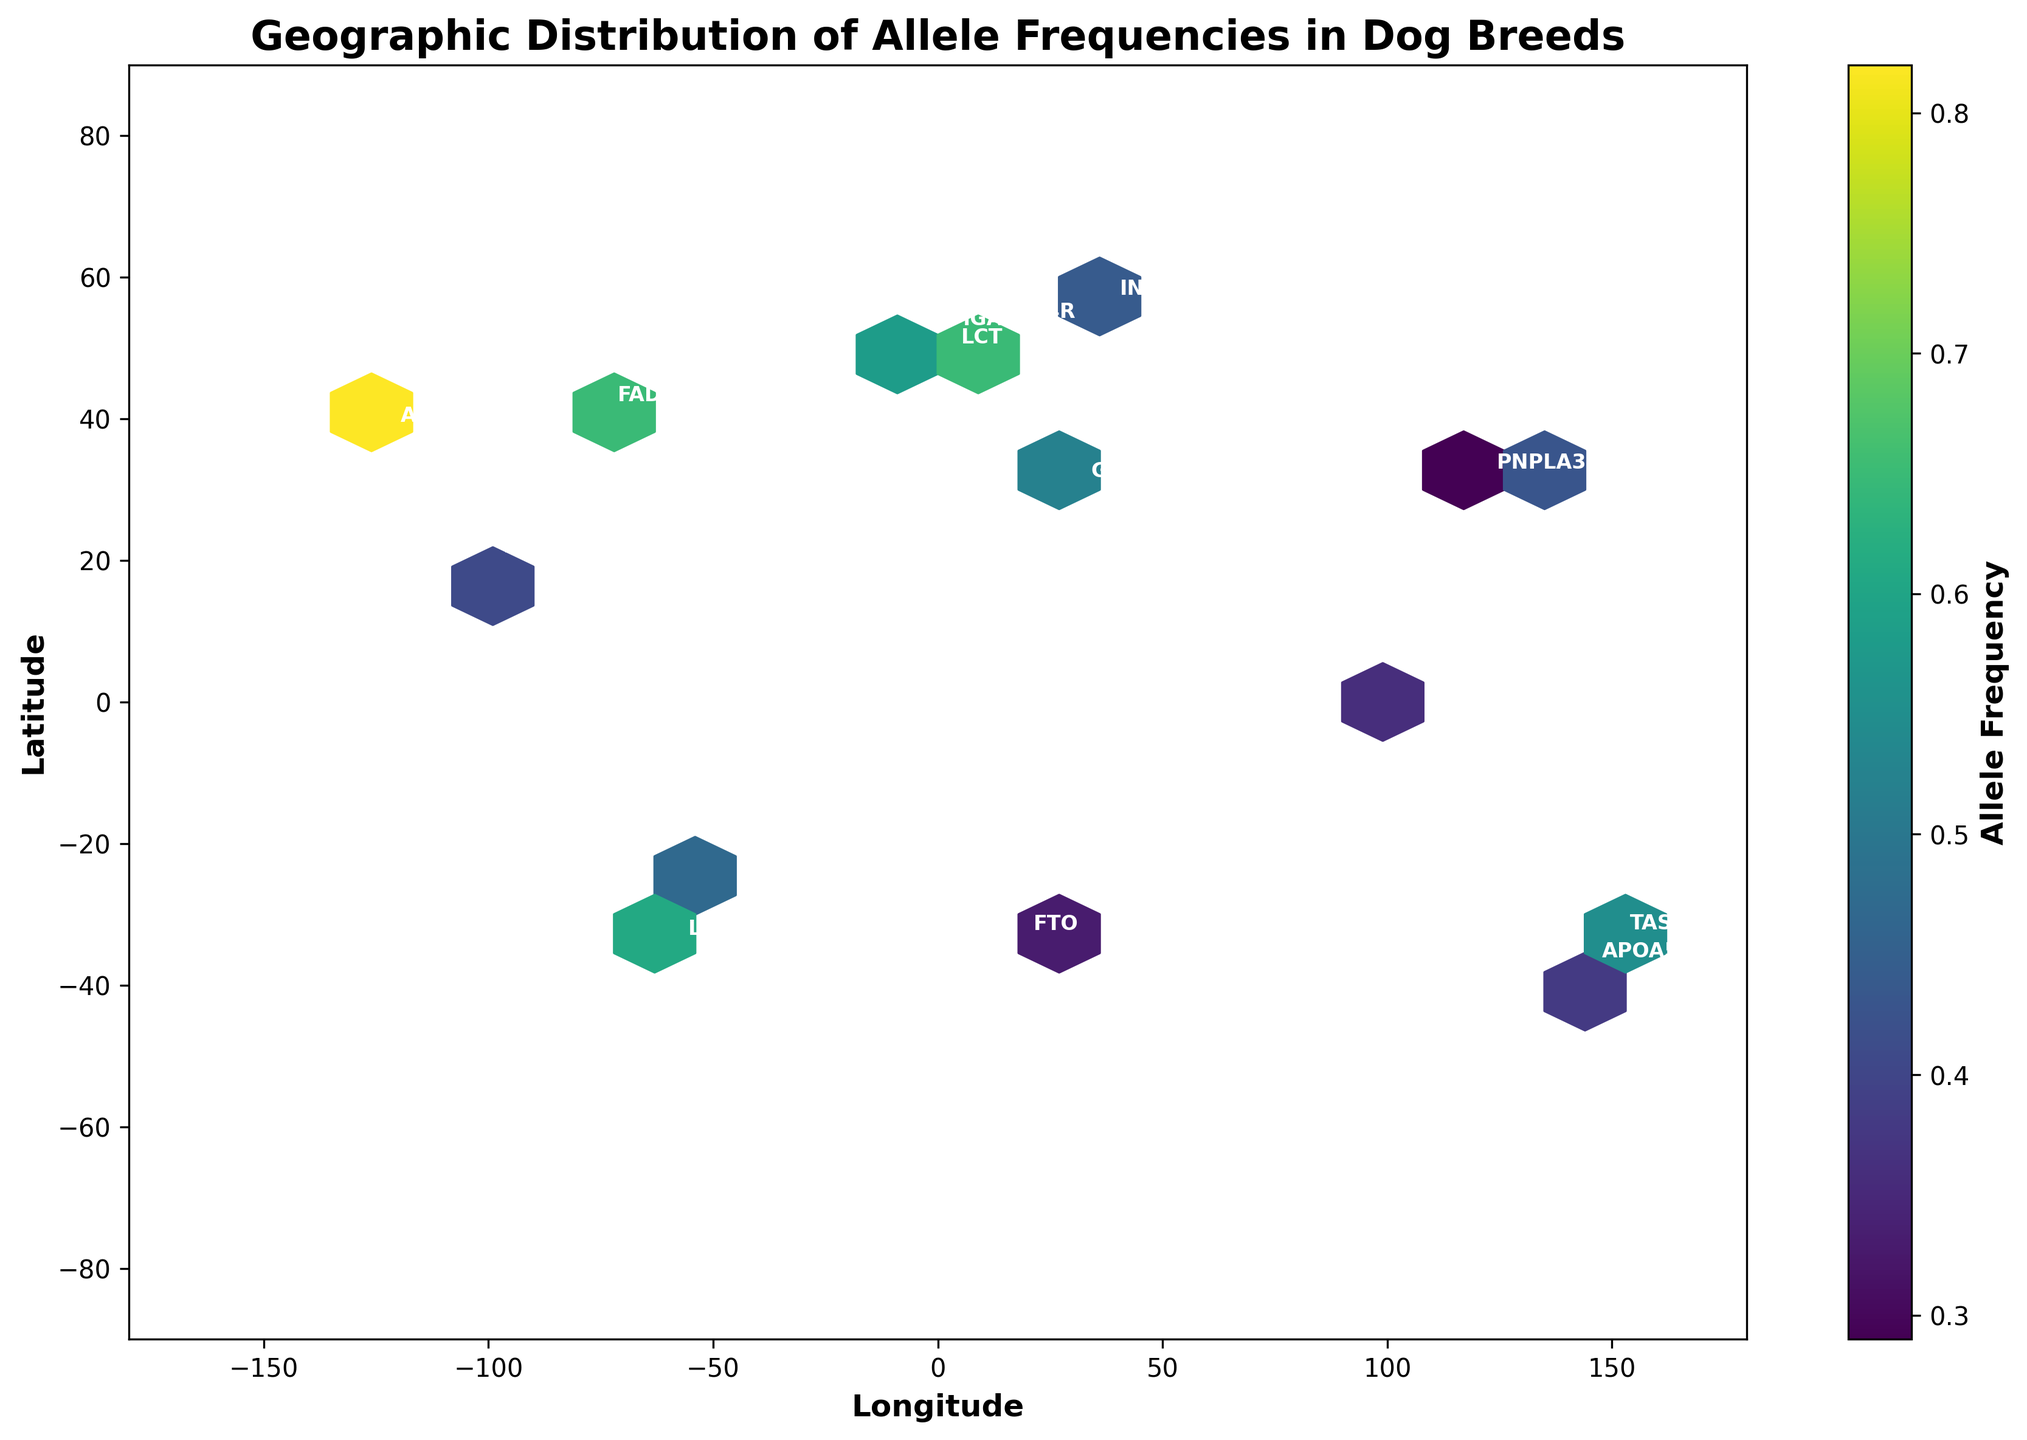What is the title of the plot? The title of the plot is usually displayed at the top of the figure, describing the main topic of the visualization. In this case, the title is "Geographic Distribution of Allele Frequencies in Dog Breeds".
Answer: Geographic Distribution of Allele Frequencies in Dog Breeds What information is shown on the x-axis and y-axis? The x-axis and y-axis are labeled to indicate what variables they represent. The x-axis is labeled "Longitude", and the y-axis is labeled "Latitude".
Answer: Longitude and Latitude Which region has the highest frequency of the AMY2B allele? To determine this, locate the annotation for "AMY2B" on the plot. Check the color of the hexagon where it is placed and compare this to the color bar, which shows frequency levels. "AMY2B" is in North America with a high-frequency color.
Answer: North America What is the latitude and longitude range covered by the plot? The plot's range can be inferred from the axis limits. The latitude ranges from -90 to 90 degrees, and the longitude ranges from -180 to 180 degrees.
Answer: -90 to 90 and -180 to 180 Which allele has the lowest frequency in Africa? Identify the two alleles present in Africa by locating their annotations. Compare the hexagon colors with the color bar. "FTO" and "GHRL" are shown, and "FTO" has the lower frequency.
Answer: FTO How is the frequency of alleles indicated on the plot? The frequency is shown using a color scale to fill the hexagonal bins. The colors range from light to dark based on the frequency, with a corresponding color bar for reference.
Answer: By color intensity in hexagons Compare the allele frequencies in South America. Which one is higher? Locate "PPARG" and "LEPR" annotations in South America. Compare the hexagon colors of these points using the color bar. "LEPR" has a darker shade indicating a higher frequency.
Answer: LEPR Estimate the average frequency of alleles in Australia. Identify the two alleles in Australia and their corresponding hexagon colors. Using the color bar, approximate the frequencies (e.g., "TAS2R38" is 0.55 and "APOA5" is 0.38) and calculate the average. (0.55+0.38)/2 = 0.465.
Answer: 0.47 Which regions show frequencies below 0.5 for the alleles present? Identify alleles in each region and examine their hexagon colors relative to the color bar. Alleles like "PNPLA3" in Asia, "APOA5" in Australia, and "UCP3" in Southeast Asia have frequencies below 0.5.
Answer: Asia, Australia, Southeast Asia 